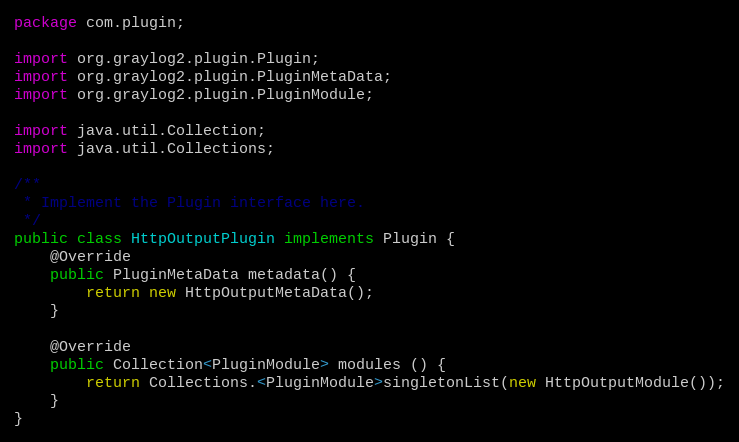<code> <loc_0><loc_0><loc_500><loc_500><_Java_>package com.plugin;

import org.graylog2.plugin.Plugin;
import org.graylog2.plugin.PluginMetaData;
import org.graylog2.plugin.PluginModule;

import java.util.Collection;
import java.util.Collections;

/**
 * Implement the Plugin interface here.
 */
public class HttpOutputPlugin implements Plugin {
    @Override
    public PluginMetaData metadata() {
        return new HttpOutputMetaData();
    }

    @Override
    public Collection<PluginModule> modules () {
        return Collections.<PluginModule>singletonList(new HttpOutputModule());
    }
}
</code> 